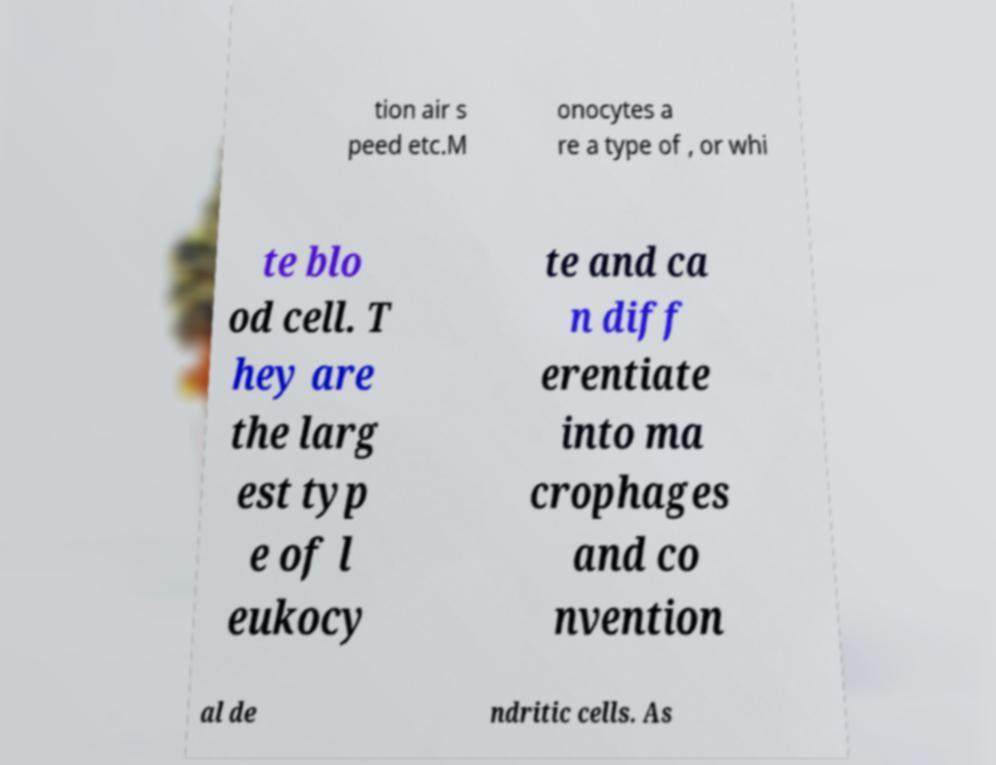I need the written content from this picture converted into text. Can you do that? tion air s peed etc.M onocytes a re a type of , or whi te blo od cell. T hey are the larg est typ e of l eukocy te and ca n diff erentiate into ma crophages and co nvention al de ndritic cells. As 